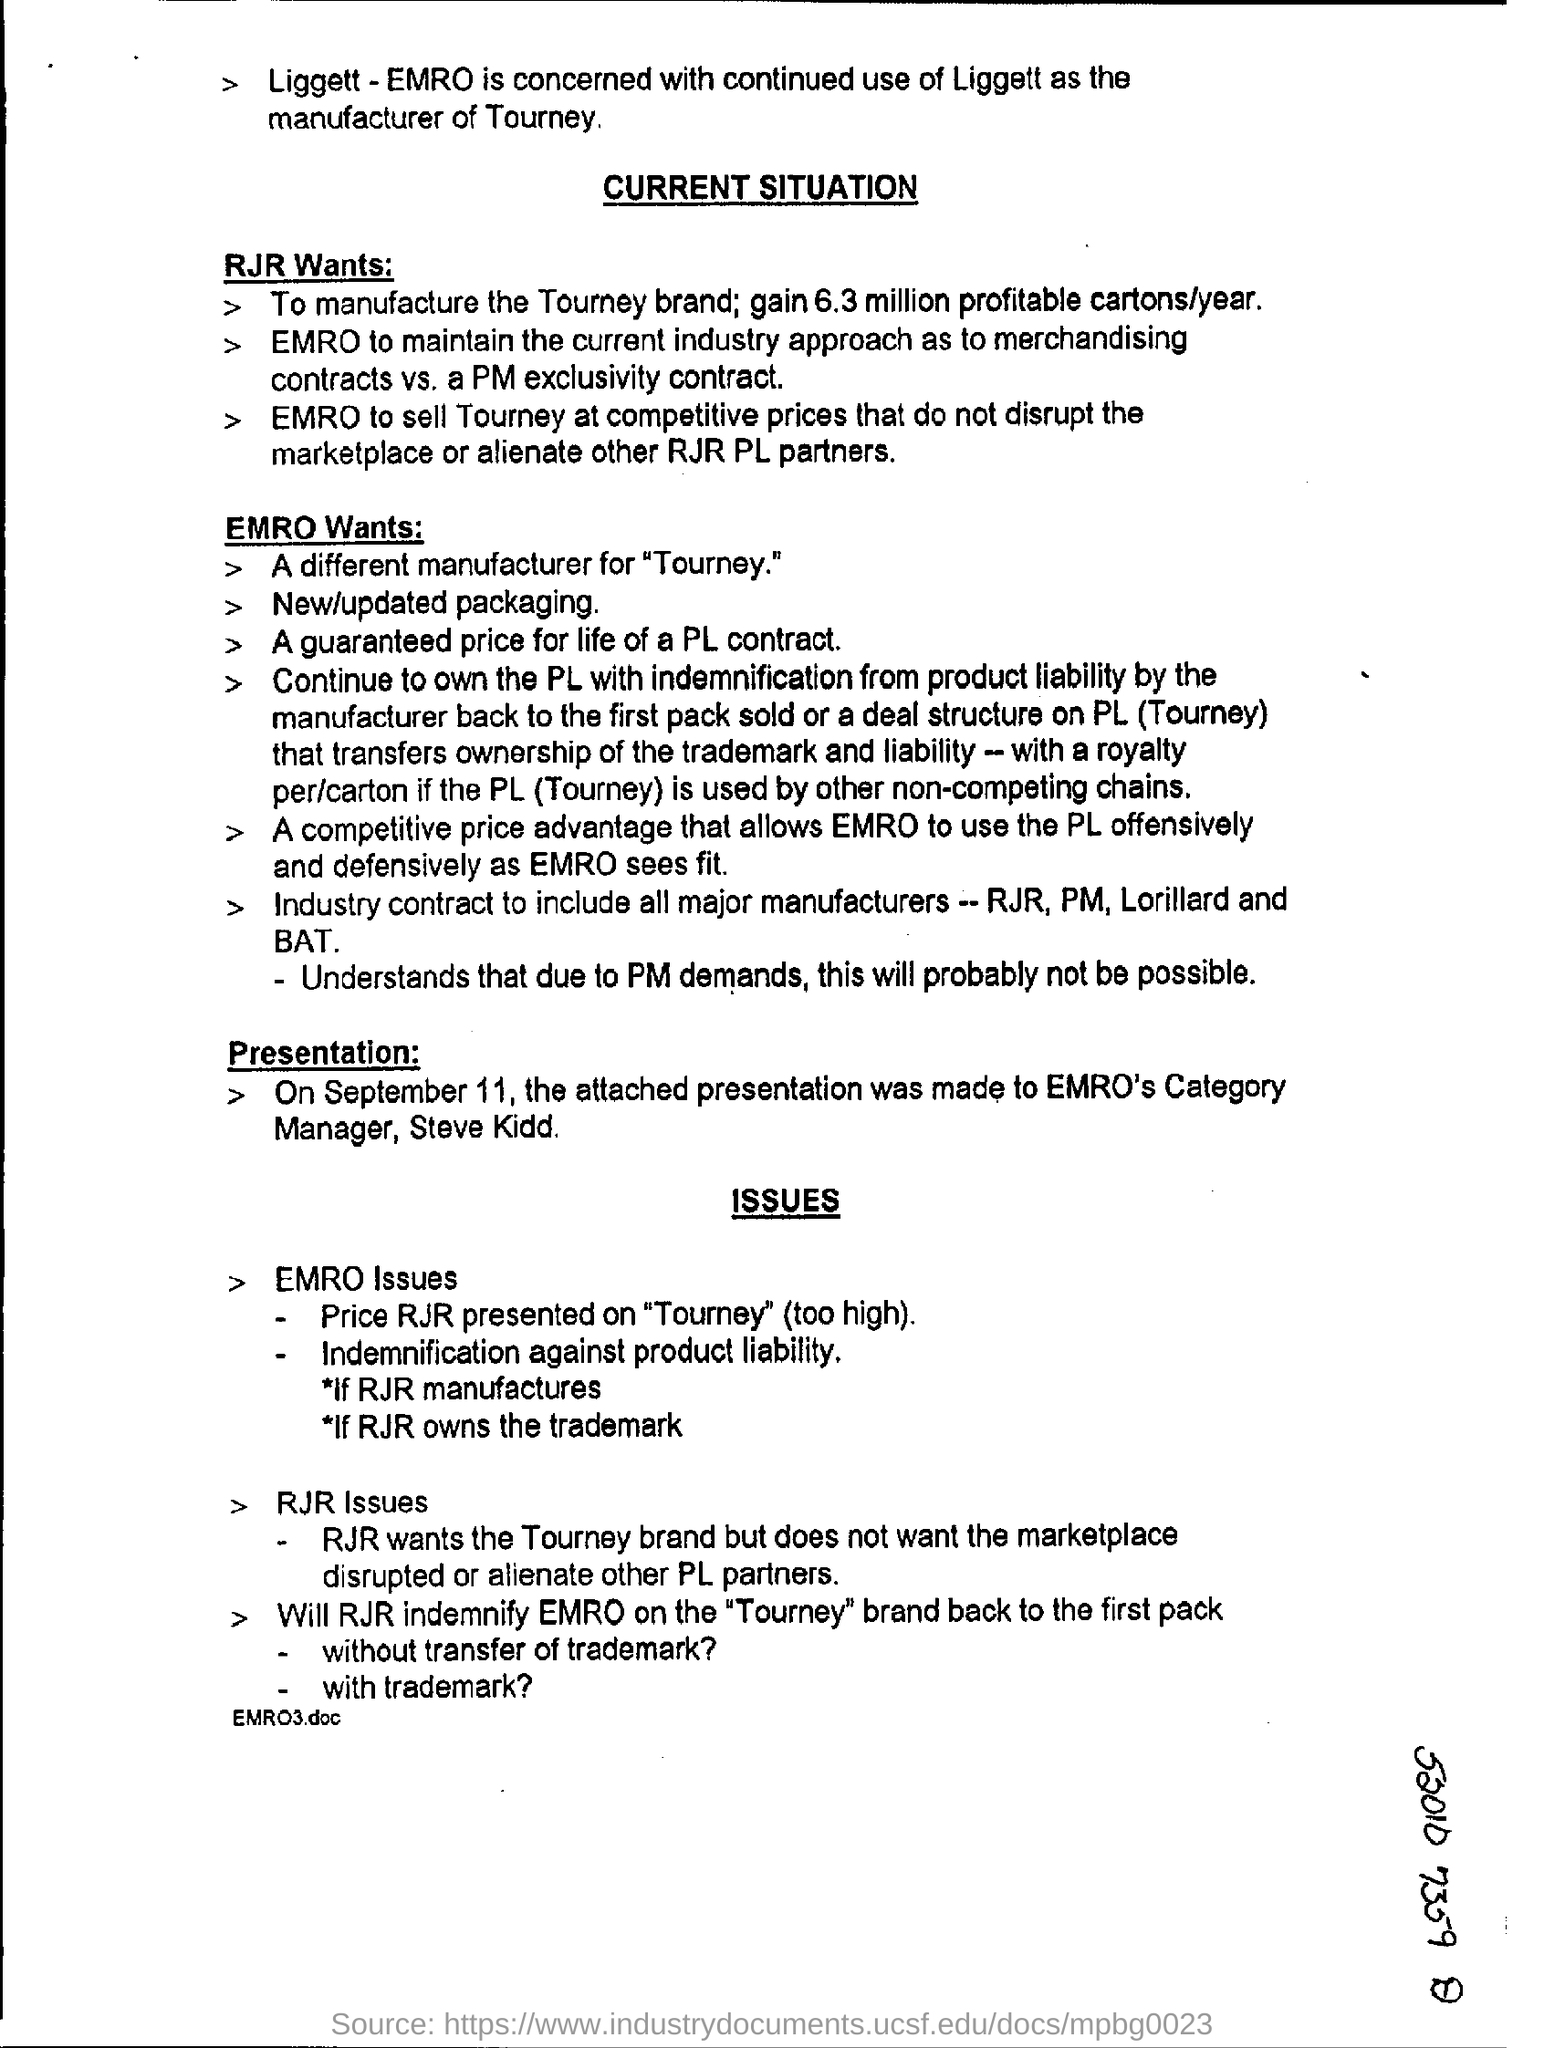Outline some significant characteristics in this image. We have determined that RJR intends to manufacture approximately 6.3 million cartons. The presentation date is September 11. 